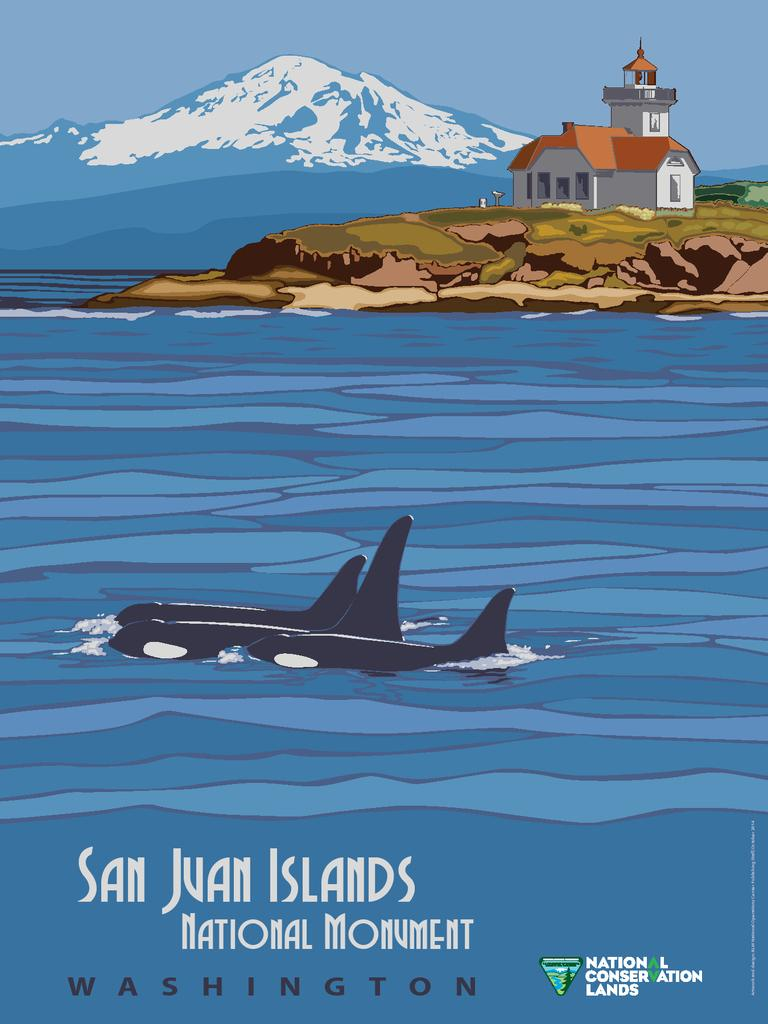<image>
Create a compact narrative representing the image presented. An advertisement for San Juan Islands features Orca whales on it. 